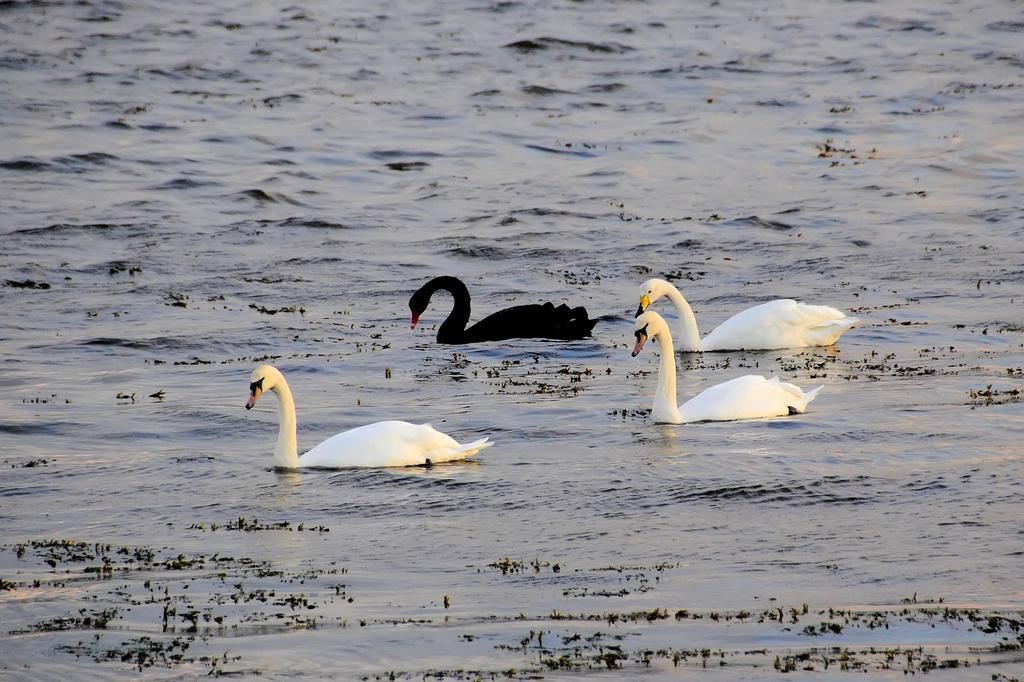How many swans are present in the image? There are four swans in the image. Where are the swans located? The swans are in a lake. What type of list can be seen in the image? There is no list present in the image; it features four swans in a lake. What is the swans using to clean themselves in the image? Swans do not use soap to clean themselves, and there is no soap present in the image. 